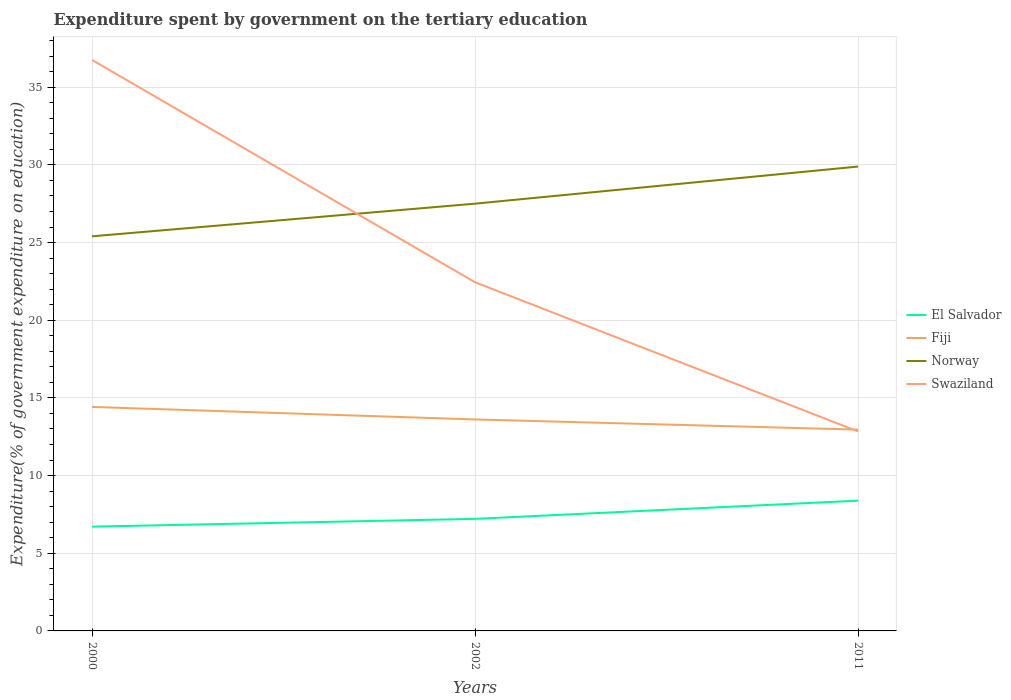How many different coloured lines are there?
Give a very brief answer. 4. Across all years, what is the maximum expenditure spent by government on the tertiary education in Fiji?
Your response must be concise. 12.96. What is the total expenditure spent by government on the tertiary education in El Salvador in the graph?
Provide a short and direct response. -1.17. What is the difference between the highest and the second highest expenditure spent by government on the tertiary education in Fiji?
Provide a short and direct response. 1.46. How many lines are there?
Ensure brevity in your answer.  4. Are the values on the major ticks of Y-axis written in scientific E-notation?
Provide a short and direct response. No. Does the graph contain any zero values?
Offer a terse response. No. Does the graph contain grids?
Offer a very short reply. Yes. Where does the legend appear in the graph?
Offer a terse response. Center right. How many legend labels are there?
Keep it short and to the point. 4. How are the legend labels stacked?
Your response must be concise. Vertical. What is the title of the graph?
Make the answer very short. Expenditure spent by government on the tertiary education. Does "China" appear as one of the legend labels in the graph?
Your response must be concise. No. What is the label or title of the Y-axis?
Provide a short and direct response. Expenditure(% of government expenditure on education). What is the Expenditure(% of government expenditure on education) in El Salvador in 2000?
Offer a terse response. 6.71. What is the Expenditure(% of government expenditure on education) in Fiji in 2000?
Give a very brief answer. 14.42. What is the Expenditure(% of government expenditure on education) of Norway in 2000?
Offer a very short reply. 25.4. What is the Expenditure(% of government expenditure on education) of Swaziland in 2000?
Your answer should be compact. 36.76. What is the Expenditure(% of government expenditure on education) of El Salvador in 2002?
Your answer should be very brief. 7.21. What is the Expenditure(% of government expenditure on education) in Fiji in 2002?
Offer a very short reply. 13.61. What is the Expenditure(% of government expenditure on education) of Norway in 2002?
Give a very brief answer. 27.5. What is the Expenditure(% of government expenditure on education) in Swaziland in 2002?
Offer a very short reply. 22.44. What is the Expenditure(% of government expenditure on education) in El Salvador in 2011?
Ensure brevity in your answer.  8.39. What is the Expenditure(% of government expenditure on education) of Fiji in 2011?
Your answer should be very brief. 12.96. What is the Expenditure(% of government expenditure on education) in Norway in 2011?
Provide a short and direct response. 29.89. What is the Expenditure(% of government expenditure on education) of Swaziland in 2011?
Your answer should be very brief. 12.84. Across all years, what is the maximum Expenditure(% of government expenditure on education) in El Salvador?
Keep it short and to the point. 8.39. Across all years, what is the maximum Expenditure(% of government expenditure on education) of Fiji?
Your response must be concise. 14.42. Across all years, what is the maximum Expenditure(% of government expenditure on education) in Norway?
Provide a succinct answer. 29.89. Across all years, what is the maximum Expenditure(% of government expenditure on education) of Swaziland?
Your answer should be compact. 36.76. Across all years, what is the minimum Expenditure(% of government expenditure on education) in El Salvador?
Offer a very short reply. 6.71. Across all years, what is the minimum Expenditure(% of government expenditure on education) in Fiji?
Your response must be concise. 12.96. Across all years, what is the minimum Expenditure(% of government expenditure on education) in Norway?
Make the answer very short. 25.4. Across all years, what is the minimum Expenditure(% of government expenditure on education) of Swaziland?
Your answer should be compact. 12.84. What is the total Expenditure(% of government expenditure on education) in El Salvador in the graph?
Provide a succinct answer. 22.31. What is the total Expenditure(% of government expenditure on education) in Fiji in the graph?
Offer a terse response. 40.99. What is the total Expenditure(% of government expenditure on education) of Norway in the graph?
Provide a short and direct response. 82.8. What is the total Expenditure(% of government expenditure on education) of Swaziland in the graph?
Your answer should be very brief. 72.04. What is the difference between the Expenditure(% of government expenditure on education) of Fiji in 2000 and that in 2002?
Give a very brief answer. 0.81. What is the difference between the Expenditure(% of government expenditure on education) of Norway in 2000 and that in 2002?
Your response must be concise. -2.1. What is the difference between the Expenditure(% of government expenditure on education) of Swaziland in 2000 and that in 2002?
Ensure brevity in your answer.  14.31. What is the difference between the Expenditure(% of government expenditure on education) in El Salvador in 2000 and that in 2011?
Your response must be concise. -1.67. What is the difference between the Expenditure(% of government expenditure on education) of Fiji in 2000 and that in 2011?
Provide a succinct answer. 1.46. What is the difference between the Expenditure(% of government expenditure on education) in Norway in 2000 and that in 2011?
Give a very brief answer. -4.49. What is the difference between the Expenditure(% of government expenditure on education) of Swaziland in 2000 and that in 2011?
Provide a short and direct response. 23.92. What is the difference between the Expenditure(% of government expenditure on education) in El Salvador in 2002 and that in 2011?
Give a very brief answer. -1.17. What is the difference between the Expenditure(% of government expenditure on education) of Fiji in 2002 and that in 2011?
Your response must be concise. 0.66. What is the difference between the Expenditure(% of government expenditure on education) of Norway in 2002 and that in 2011?
Provide a short and direct response. -2.39. What is the difference between the Expenditure(% of government expenditure on education) in Swaziland in 2002 and that in 2011?
Give a very brief answer. 9.61. What is the difference between the Expenditure(% of government expenditure on education) of El Salvador in 2000 and the Expenditure(% of government expenditure on education) of Fiji in 2002?
Give a very brief answer. -6.9. What is the difference between the Expenditure(% of government expenditure on education) of El Salvador in 2000 and the Expenditure(% of government expenditure on education) of Norway in 2002?
Provide a succinct answer. -20.79. What is the difference between the Expenditure(% of government expenditure on education) in El Salvador in 2000 and the Expenditure(% of government expenditure on education) in Swaziland in 2002?
Provide a succinct answer. -15.73. What is the difference between the Expenditure(% of government expenditure on education) in Fiji in 2000 and the Expenditure(% of government expenditure on education) in Norway in 2002?
Ensure brevity in your answer.  -13.08. What is the difference between the Expenditure(% of government expenditure on education) of Fiji in 2000 and the Expenditure(% of government expenditure on education) of Swaziland in 2002?
Provide a succinct answer. -8.02. What is the difference between the Expenditure(% of government expenditure on education) of Norway in 2000 and the Expenditure(% of government expenditure on education) of Swaziland in 2002?
Your answer should be compact. 2.96. What is the difference between the Expenditure(% of government expenditure on education) of El Salvador in 2000 and the Expenditure(% of government expenditure on education) of Fiji in 2011?
Make the answer very short. -6.24. What is the difference between the Expenditure(% of government expenditure on education) of El Salvador in 2000 and the Expenditure(% of government expenditure on education) of Norway in 2011?
Ensure brevity in your answer.  -23.18. What is the difference between the Expenditure(% of government expenditure on education) in El Salvador in 2000 and the Expenditure(% of government expenditure on education) in Swaziland in 2011?
Provide a short and direct response. -6.13. What is the difference between the Expenditure(% of government expenditure on education) of Fiji in 2000 and the Expenditure(% of government expenditure on education) of Norway in 2011?
Your answer should be very brief. -15.47. What is the difference between the Expenditure(% of government expenditure on education) in Fiji in 2000 and the Expenditure(% of government expenditure on education) in Swaziland in 2011?
Give a very brief answer. 1.58. What is the difference between the Expenditure(% of government expenditure on education) in Norway in 2000 and the Expenditure(% of government expenditure on education) in Swaziland in 2011?
Make the answer very short. 12.56. What is the difference between the Expenditure(% of government expenditure on education) of El Salvador in 2002 and the Expenditure(% of government expenditure on education) of Fiji in 2011?
Your answer should be very brief. -5.74. What is the difference between the Expenditure(% of government expenditure on education) of El Salvador in 2002 and the Expenditure(% of government expenditure on education) of Norway in 2011?
Ensure brevity in your answer.  -22.68. What is the difference between the Expenditure(% of government expenditure on education) of El Salvador in 2002 and the Expenditure(% of government expenditure on education) of Swaziland in 2011?
Ensure brevity in your answer.  -5.63. What is the difference between the Expenditure(% of government expenditure on education) in Fiji in 2002 and the Expenditure(% of government expenditure on education) in Norway in 2011?
Provide a succinct answer. -16.28. What is the difference between the Expenditure(% of government expenditure on education) of Fiji in 2002 and the Expenditure(% of government expenditure on education) of Swaziland in 2011?
Offer a very short reply. 0.77. What is the difference between the Expenditure(% of government expenditure on education) in Norway in 2002 and the Expenditure(% of government expenditure on education) in Swaziland in 2011?
Ensure brevity in your answer.  14.66. What is the average Expenditure(% of government expenditure on education) in El Salvador per year?
Your response must be concise. 7.44. What is the average Expenditure(% of government expenditure on education) in Fiji per year?
Offer a terse response. 13.66. What is the average Expenditure(% of government expenditure on education) of Norway per year?
Make the answer very short. 27.6. What is the average Expenditure(% of government expenditure on education) of Swaziland per year?
Ensure brevity in your answer.  24.01. In the year 2000, what is the difference between the Expenditure(% of government expenditure on education) of El Salvador and Expenditure(% of government expenditure on education) of Fiji?
Make the answer very short. -7.71. In the year 2000, what is the difference between the Expenditure(% of government expenditure on education) in El Salvador and Expenditure(% of government expenditure on education) in Norway?
Provide a short and direct response. -18.69. In the year 2000, what is the difference between the Expenditure(% of government expenditure on education) of El Salvador and Expenditure(% of government expenditure on education) of Swaziland?
Give a very brief answer. -30.04. In the year 2000, what is the difference between the Expenditure(% of government expenditure on education) in Fiji and Expenditure(% of government expenditure on education) in Norway?
Give a very brief answer. -10.98. In the year 2000, what is the difference between the Expenditure(% of government expenditure on education) in Fiji and Expenditure(% of government expenditure on education) in Swaziland?
Offer a terse response. -22.34. In the year 2000, what is the difference between the Expenditure(% of government expenditure on education) of Norway and Expenditure(% of government expenditure on education) of Swaziland?
Give a very brief answer. -11.35. In the year 2002, what is the difference between the Expenditure(% of government expenditure on education) in El Salvador and Expenditure(% of government expenditure on education) in Fiji?
Keep it short and to the point. -6.4. In the year 2002, what is the difference between the Expenditure(% of government expenditure on education) of El Salvador and Expenditure(% of government expenditure on education) of Norway?
Give a very brief answer. -20.29. In the year 2002, what is the difference between the Expenditure(% of government expenditure on education) in El Salvador and Expenditure(% of government expenditure on education) in Swaziland?
Give a very brief answer. -15.23. In the year 2002, what is the difference between the Expenditure(% of government expenditure on education) of Fiji and Expenditure(% of government expenditure on education) of Norway?
Your answer should be very brief. -13.89. In the year 2002, what is the difference between the Expenditure(% of government expenditure on education) in Fiji and Expenditure(% of government expenditure on education) in Swaziland?
Offer a very short reply. -8.83. In the year 2002, what is the difference between the Expenditure(% of government expenditure on education) of Norway and Expenditure(% of government expenditure on education) of Swaziland?
Provide a short and direct response. 5.06. In the year 2011, what is the difference between the Expenditure(% of government expenditure on education) in El Salvador and Expenditure(% of government expenditure on education) in Fiji?
Ensure brevity in your answer.  -4.57. In the year 2011, what is the difference between the Expenditure(% of government expenditure on education) of El Salvador and Expenditure(% of government expenditure on education) of Norway?
Offer a terse response. -21.51. In the year 2011, what is the difference between the Expenditure(% of government expenditure on education) in El Salvador and Expenditure(% of government expenditure on education) in Swaziland?
Offer a terse response. -4.45. In the year 2011, what is the difference between the Expenditure(% of government expenditure on education) in Fiji and Expenditure(% of government expenditure on education) in Norway?
Your response must be concise. -16.93. In the year 2011, what is the difference between the Expenditure(% of government expenditure on education) in Fiji and Expenditure(% of government expenditure on education) in Swaziland?
Make the answer very short. 0.12. In the year 2011, what is the difference between the Expenditure(% of government expenditure on education) of Norway and Expenditure(% of government expenditure on education) of Swaziland?
Ensure brevity in your answer.  17.05. What is the ratio of the Expenditure(% of government expenditure on education) of El Salvador in 2000 to that in 2002?
Your response must be concise. 0.93. What is the ratio of the Expenditure(% of government expenditure on education) in Fiji in 2000 to that in 2002?
Give a very brief answer. 1.06. What is the ratio of the Expenditure(% of government expenditure on education) of Norway in 2000 to that in 2002?
Offer a very short reply. 0.92. What is the ratio of the Expenditure(% of government expenditure on education) of Swaziland in 2000 to that in 2002?
Keep it short and to the point. 1.64. What is the ratio of the Expenditure(% of government expenditure on education) of El Salvador in 2000 to that in 2011?
Provide a succinct answer. 0.8. What is the ratio of the Expenditure(% of government expenditure on education) in Fiji in 2000 to that in 2011?
Your answer should be very brief. 1.11. What is the ratio of the Expenditure(% of government expenditure on education) of Norway in 2000 to that in 2011?
Give a very brief answer. 0.85. What is the ratio of the Expenditure(% of government expenditure on education) of Swaziland in 2000 to that in 2011?
Give a very brief answer. 2.86. What is the ratio of the Expenditure(% of government expenditure on education) in El Salvador in 2002 to that in 2011?
Offer a very short reply. 0.86. What is the ratio of the Expenditure(% of government expenditure on education) in Fiji in 2002 to that in 2011?
Keep it short and to the point. 1.05. What is the ratio of the Expenditure(% of government expenditure on education) in Norway in 2002 to that in 2011?
Ensure brevity in your answer.  0.92. What is the ratio of the Expenditure(% of government expenditure on education) in Swaziland in 2002 to that in 2011?
Ensure brevity in your answer.  1.75. What is the difference between the highest and the second highest Expenditure(% of government expenditure on education) of El Salvador?
Offer a very short reply. 1.17. What is the difference between the highest and the second highest Expenditure(% of government expenditure on education) in Fiji?
Your answer should be very brief. 0.81. What is the difference between the highest and the second highest Expenditure(% of government expenditure on education) of Norway?
Make the answer very short. 2.39. What is the difference between the highest and the second highest Expenditure(% of government expenditure on education) in Swaziland?
Ensure brevity in your answer.  14.31. What is the difference between the highest and the lowest Expenditure(% of government expenditure on education) of El Salvador?
Your answer should be very brief. 1.67. What is the difference between the highest and the lowest Expenditure(% of government expenditure on education) in Fiji?
Give a very brief answer. 1.46. What is the difference between the highest and the lowest Expenditure(% of government expenditure on education) in Norway?
Your answer should be compact. 4.49. What is the difference between the highest and the lowest Expenditure(% of government expenditure on education) of Swaziland?
Offer a very short reply. 23.92. 